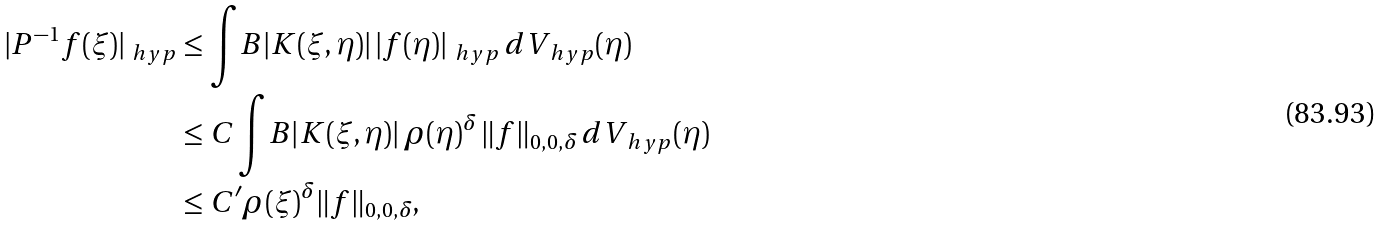Convert formula to latex. <formula><loc_0><loc_0><loc_500><loc_500>| P ^ { - 1 } f ( \xi ) | _ { \ h y p } & \leq \int _ { \ } B | K ( \xi , \eta ) | \, | f ( \eta ) | _ { \ h y p } \, d V _ { \ h y p } ( \eta ) \\ & \leq C \int _ { \ } B | K ( \xi , \eta ) | \, \rho ( \eta ) ^ { \delta } \, \| f \| _ { 0 , 0 , \delta } \, d V _ { \ h y p } ( \eta ) \\ & \leq C ^ { \prime } \rho ( \xi ) ^ { \delta } \| f \| _ { 0 , 0 , \delta } ,</formula> 